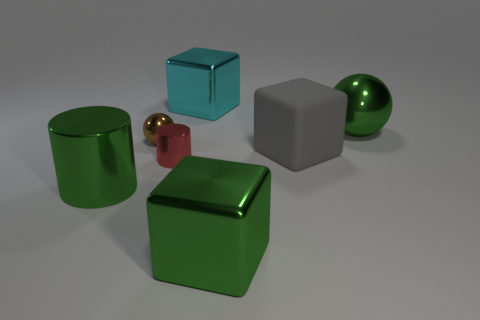Subtract all large green shiny cubes. How many cubes are left? 2 Add 3 cyan things. How many objects exist? 10 Subtract all cyan blocks. How many blocks are left? 2 Subtract 1 spheres. How many spheres are left? 1 Add 6 large red things. How many large red things exist? 6 Subtract 1 green cylinders. How many objects are left? 6 Subtract all balls. How many objects are left? 5 Subtract all purple cubes. Subtract all green cylinders. How many cubes are left? 3 Subtract all yellow cylinders. How many gray blocks are left? 1 Subtract all brown things. Subtract all tiny red cylinders. How many objects are left? 5 